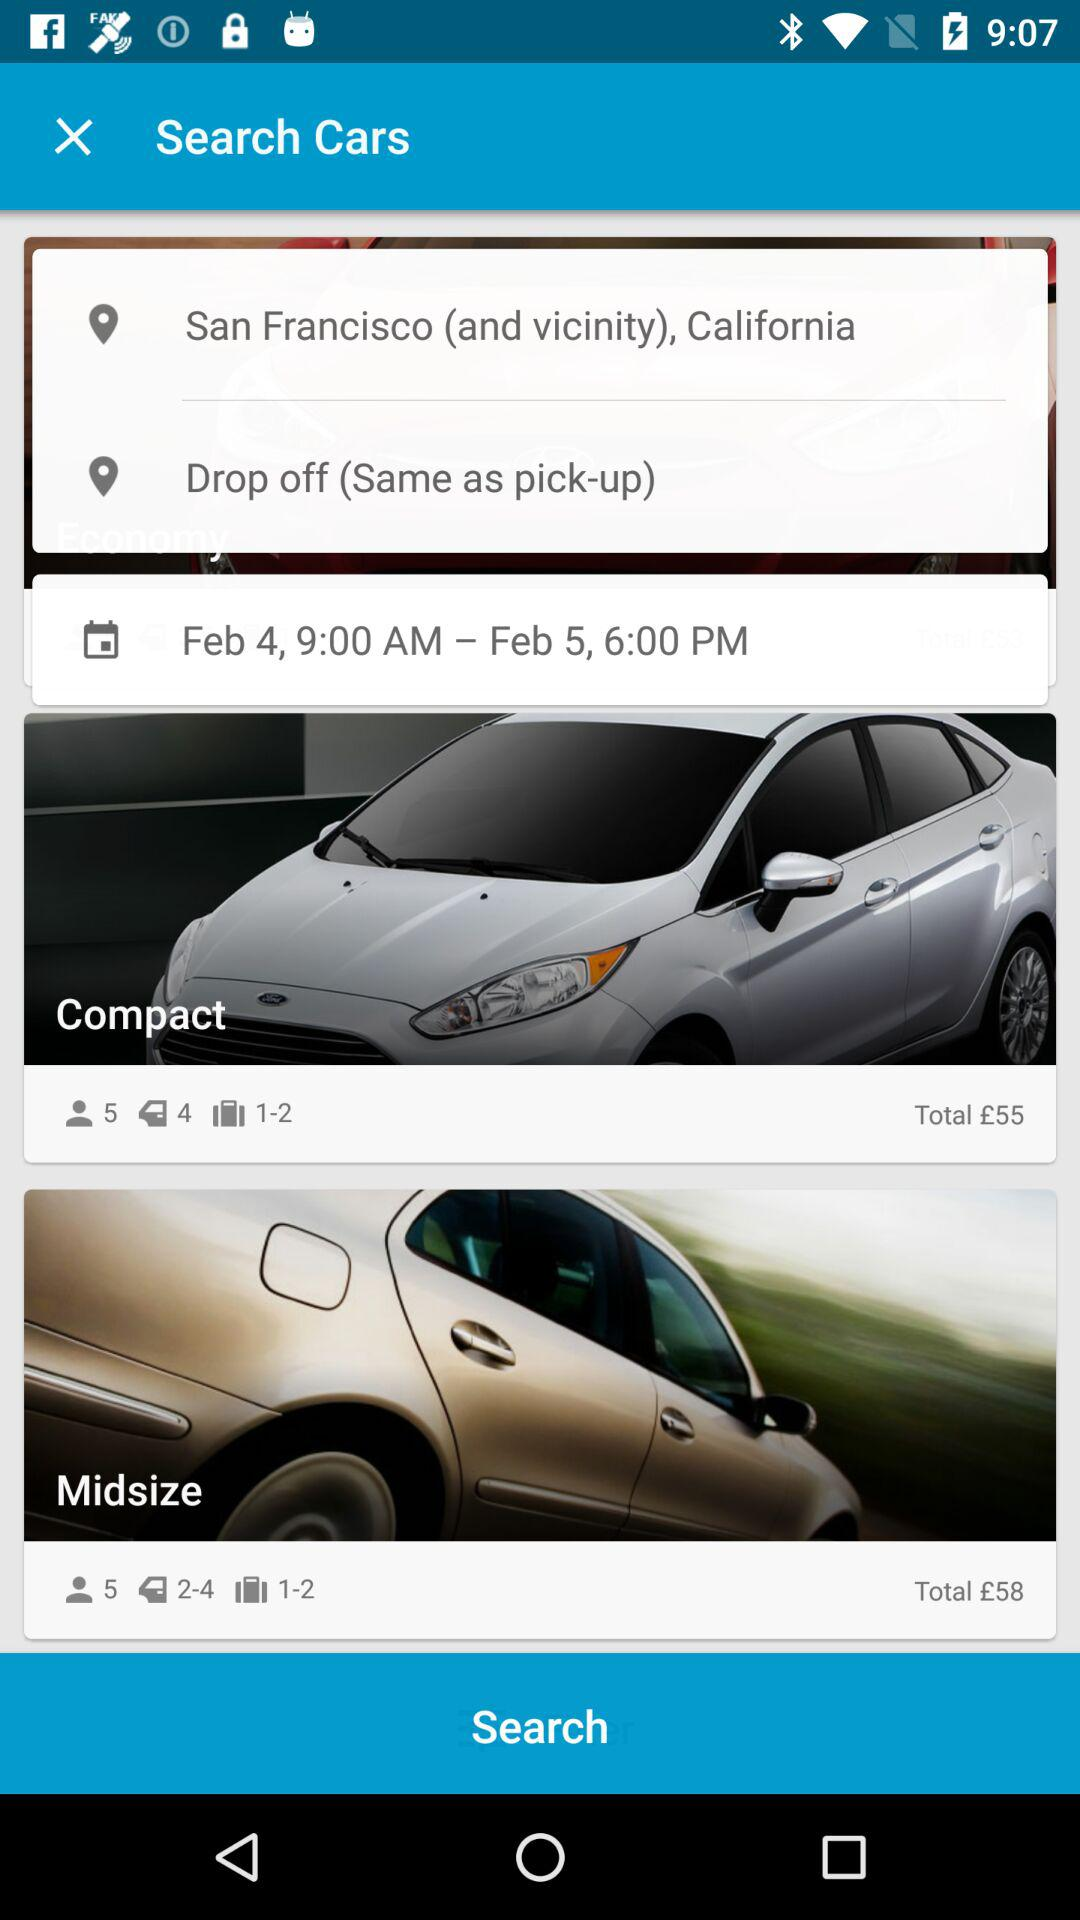What is the date and time for traveling? The date and time for travelling are from February 4, 9:00 AM to February 5, 6:00 PM. 